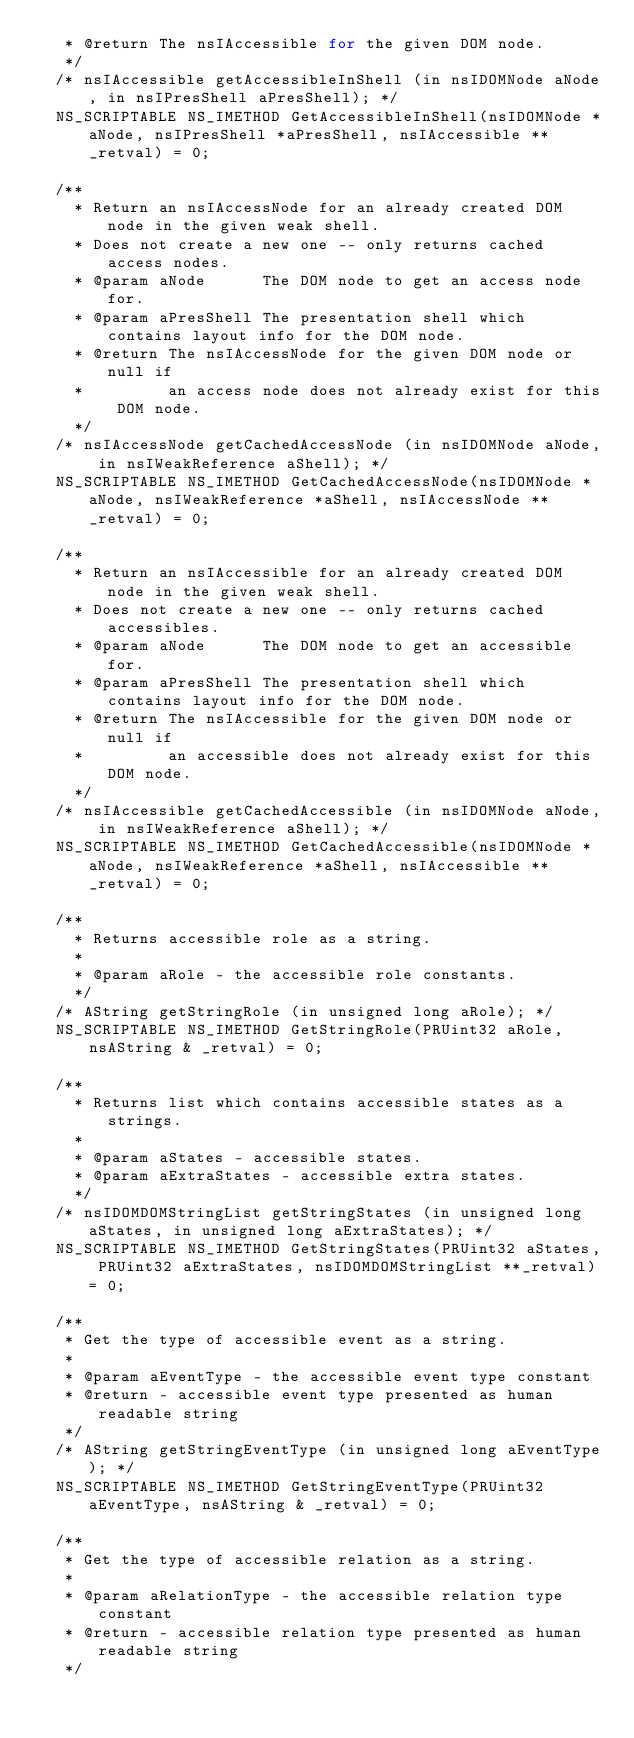Convert code to text. <code><loc_0><loc_0><loc_500><loc_500><_C_>   * @return The nsIAccessible for the given DOM node.
   */
  /* nsIAccessible getAccessibleInShell (in nsIDOMNode aNode, in nsIPresShell aPresShell); */
  NS_SCRIPTABLE NS_IMETHOD GetAccessibleInShell(nsIDOMNode *aNode, nsIPresShell *aPresShell, nsIAccessible **_retval) = 0;

  /**
    * Return an nsIAccessNode for an already created DOM node in the given weak shell.
    * Does not create a new one -- only returns cached access nodes.
    * @param aNode      The DOM node to get an access node for.
    * @param aPresShell The presentation shell which contains layout info for the DOM node.
    * @return The nsIAccessNode for the given DOM node or null if
    *         an access node does not already exist for this DOM node.
    */
  /* nsIAccessNode getCachedAccessNode (in nsIDOMNode aNode, in nsIWeakReference aShell); */
  NS_SCRIPTABLE NS_IMETHOD GetCachedAccessNode(nsIDOMNode *aNode, nsIWeakReference *aShell, nsIAccessNode **_retval) = 0;

  /**
    * Return an nsIAccessible for an already created DOM node in the given weak shell.
    * Does not create a new one -- only returns cached accessibles.
    * @param aNode      The DOM node to get an accessible for.
    * @param aPresShell The presentation shell which contains layout info for the DOM node.
    * @return The nsIAccessible for the given DOM node or null if
    *         an accessible does not already exist for this DOM node.
    */
  /* nsIAccessible getCachedAccessible (in nsIDOMNode aNode, in nsIWeakReference aShell); */
  NS_SCRIPTABLE NS_IMETHOD GetCachedAccessible(nsIDOMNode *aNode, nsIWeakReference *aShell, nsIAccessible **_retval) = 0;

  /**
    * Returns accessible role as a string.
    *
    * @param aRole - the accessible role constants.
    */
  /* AString getStringRole (in unsigned long aRole); */
  NS_SCRIPTABLE NS_IMETHOD GetStringRole(PRUint32 aRole, nsAString & _retval) = 0;

  /**
    * Returns list which contains accessible states as a strings.
    *
    * @param aStates - accessible states.
    * @param aExtraStates - accessible extra states.
    */
  /* nsIDOMDOMStringList getStringStates (in unsigned long aStates, in unsigned long aExtraStates); */
  NS_SCRIPTABLE NS_IMETHOD GetStringStates(PRUint32 aStates, PRUint32 aExtraStates, nsIDOMDOMStringList **_retval) = 0;

  /**
   * Get the type of accessible event as a string.
   *
   * @param aEventType - the accessible event type constant
   * @return - accessible event type presented as human readable string
   */
  /* AString getStringEventType (in unsigned long aEventType); */
  NS_SCRIPTABLE NS_IMETHOD GetStringEventType(PRUint32 aEventType, nsAString & _retval) = 0;

  /**
   * Get the type of accessible relation as a string.
   *
   * @param aRelationType - the accessible relation type constant
   * @return - accessible relation type presented as human readable string
   */</code> 